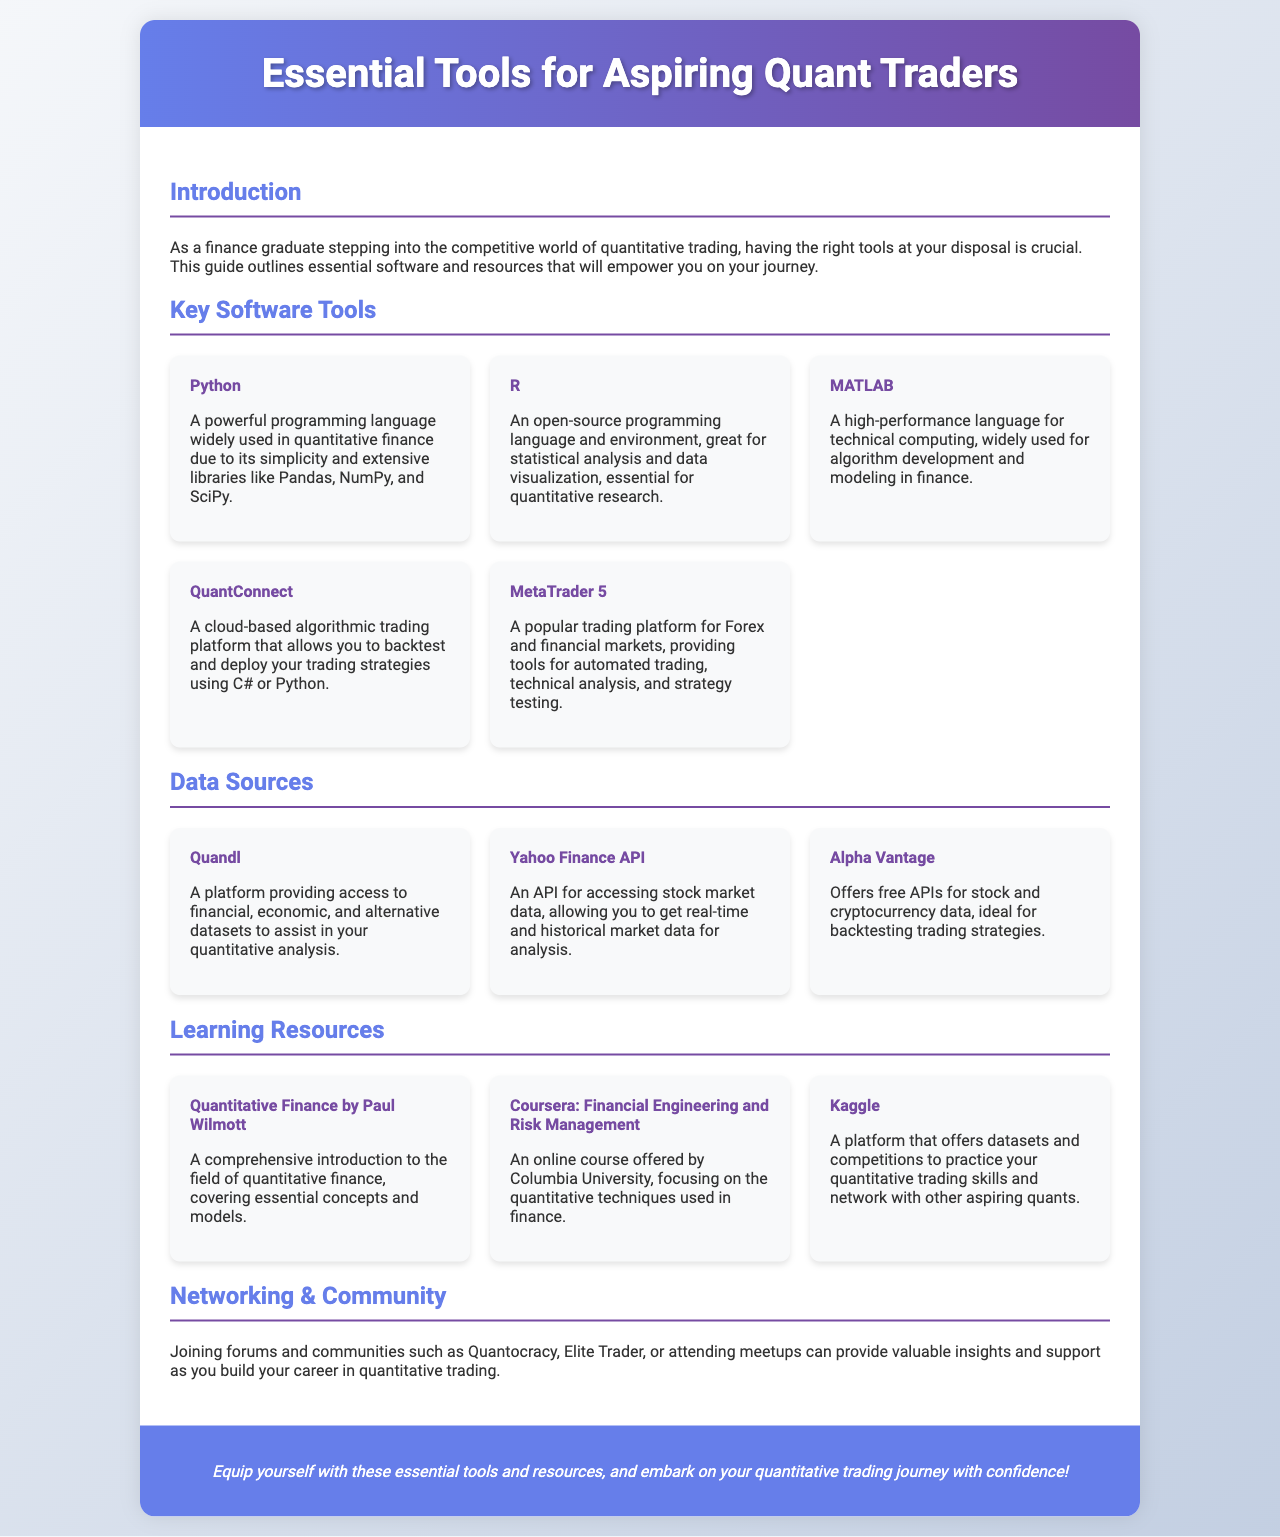What is the title of the brochure? The title is specified in the document header section, which highlights the main topic of discussion.
Answer: Essential Tools for Aspiring Quant Traders Which programming language is described as having extensive libraries like Pandas, NumPy, and SciPy? The brochure mentions this programming language in the Key Software Tools section as crucial for quantitative finance.
Answer: Python What platform allows you to backtest and deploy trading strategies using C# or Python? This information is found under the Key Software Tools section, focusing on a specific cloud-based algorithmic trading platform.
Answer: QuantConnect What does the Yahoo Finance API provide access to? The document outlines the purpose of this API within the Data Sources section, highlighting the type of data available.
Answer: stock market data Which resource is a comprehensive introduction to the field of quantitative finance? This question refers to the Learning Resources section, where different resources for learning are listed.
Answer: Quantitative Finance by Paul Wilmott What type of communities can provide insights and support in quantitative trading? The document mentions specific types of communities in the Networking & Community section that can assist aspiring traders.
Answer: forums and communities Which online course focuses on quantitative techniques used in finance? The Learning Resources section lists online courses available, and this one particularly addresses quantitative finance methods.
Answer: Coursera: Financial Engineering and Risk Management What is the overall purpose of this brochure? The introduction section conveys the main objective of the brochure, synthesizing the essential information provided.
Answer: To empower aspiring quant traders with tools and resources 